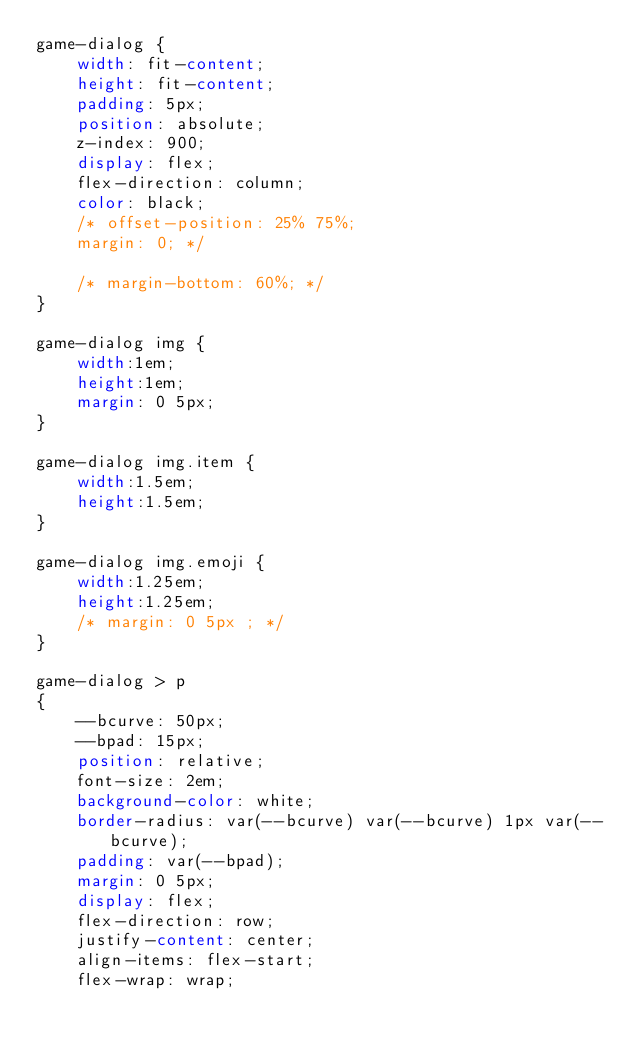<code> <loc_0><loc_0><loc_500><loc_500><_CSS_>game-dialog {
    width: fit-content;
    height: fit-content;
    padding: 5px;
    position: absolute;
    z-index: 900;
    display: flex;
    flex-direction: column;
    color: black;
    /* offset-position: 25% 75%;
    margin: 0; */

    /* margin-bottom: 60%; */
}

game-dialog img {
    width:1em;
    height:1em;
    margin: 0 5px;
}

game-dialog img.item {
    width:1.5em;
    height:1.5em;
}

game-dialog img.emoji {
    width:1.25em;
    height:1.25em;
    /* margin: 0 5px ; */
}

game-dialog > p 
{
    --bcurve: 50px;
    --bpad: 15px;
    position: relative;
    font-size: 2em;
    background-color: white;
    border-radius: var(--bcurve) var(--bcurve) 1px var(--bcurve);
    padding: var(--bpad);
    margin: 0 5px;
    display: flex;
    flex-direction: row;
    justify-content: center;
    align-items: flex-start;
    flex-wrap: wrap;</code> 